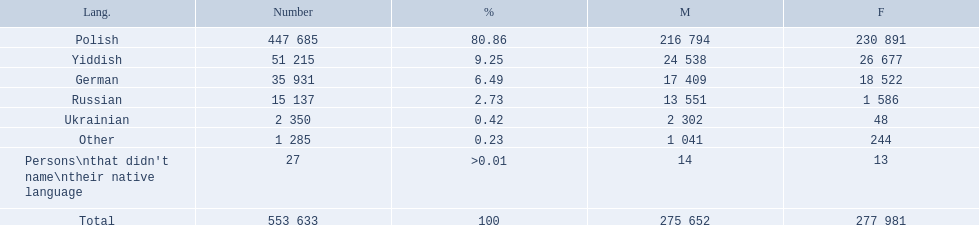What was the highest percentage of one language spoken by the plock governorate? 80.86. What language was spoken by 80.86 percent of the people? Polish. What was the least spoken language Ukrainian. What was the most spoken? Polish. 